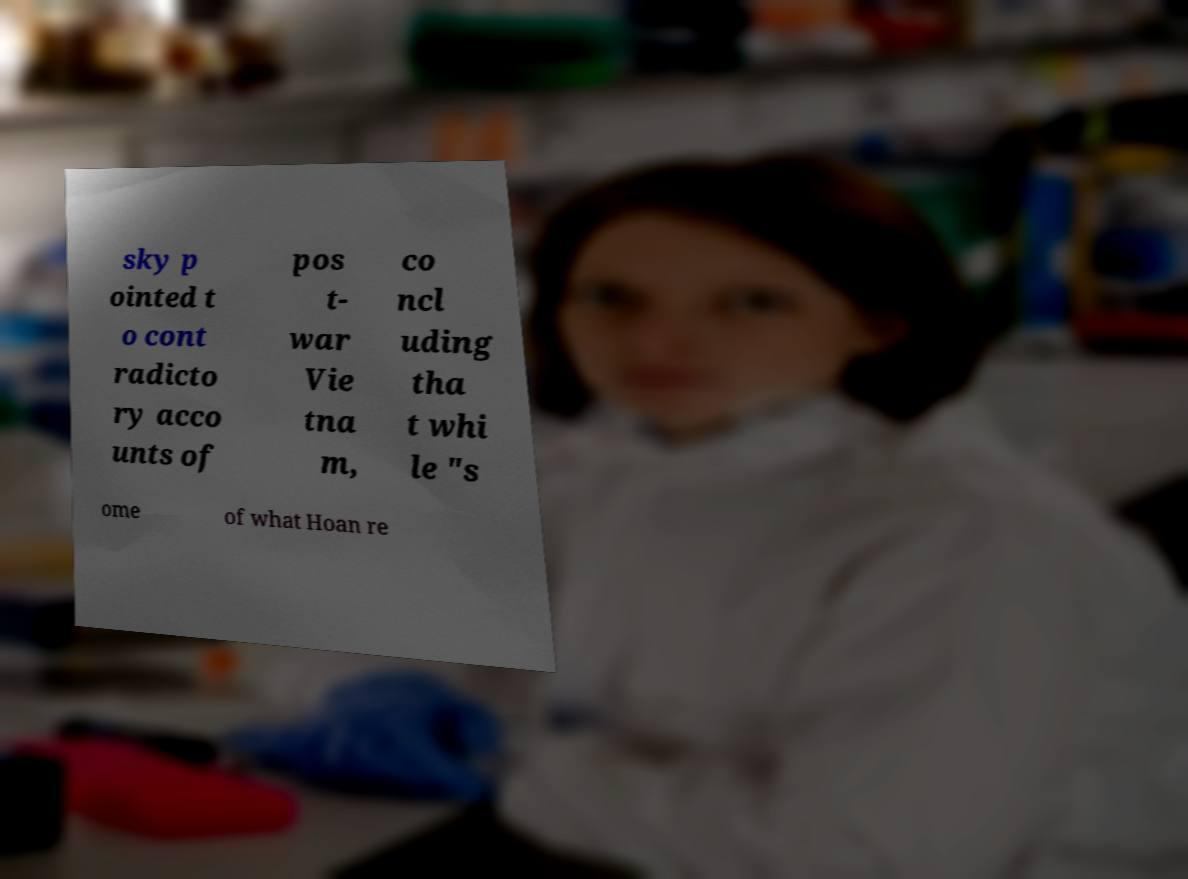There's text embedded in this image that I need extracted. Can you transcribe it verbatim? sky p ointed t o cont radicto ry acco unts of pos t- war Vie tna m, co ncl uding tha t whi le "s ome of what Hoan re 